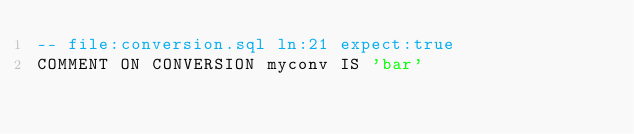<code> <loc_0><loc_0><loc_500><loc_500><_SQL_>-- file:conversion.sql ln:21 expect:true
COMMENT ON CONVERSION myconv IS 'bar'
</code> 